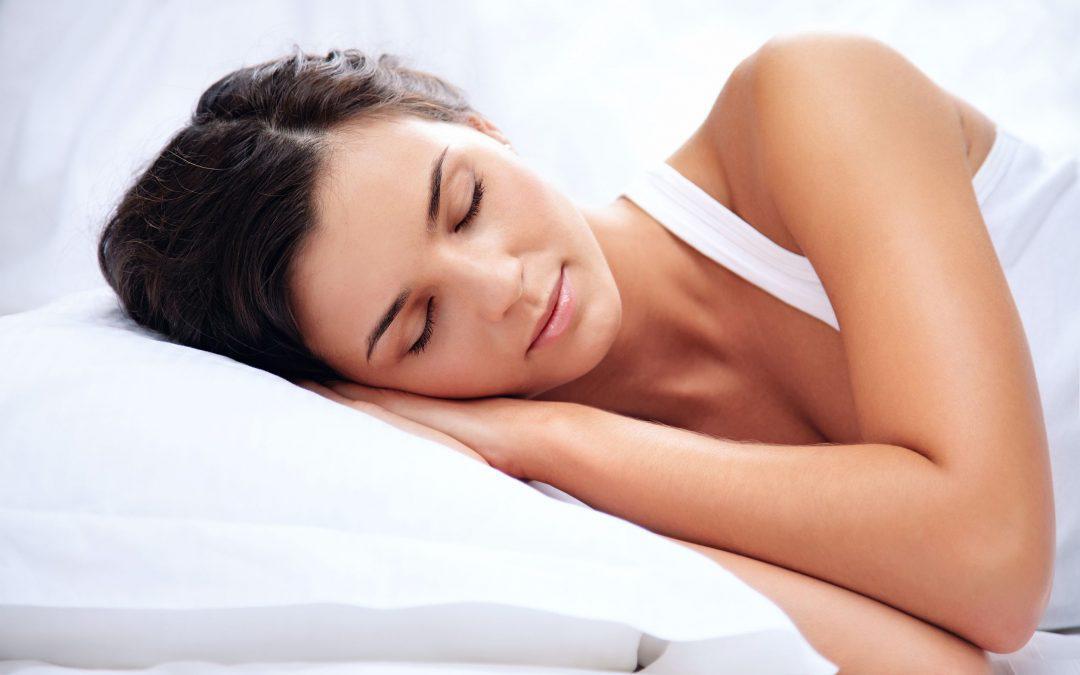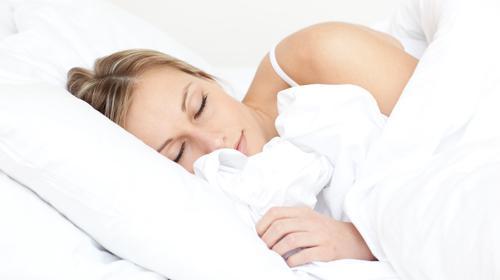The first image is the image on the left, the second image is the image on the right. For the images shown, is this caption "A single person is sleeping on a pillow in each of the images." true? Answer yes or no. Yes. The first image is the image on the left, the second image is the image on the right. Evaluate the accuracy of this statement regarding the images: "Each image shows only an adult female sleeper, and at least one image shows a side-sleeper.". Is it true? Answer yes or no. Yes. 